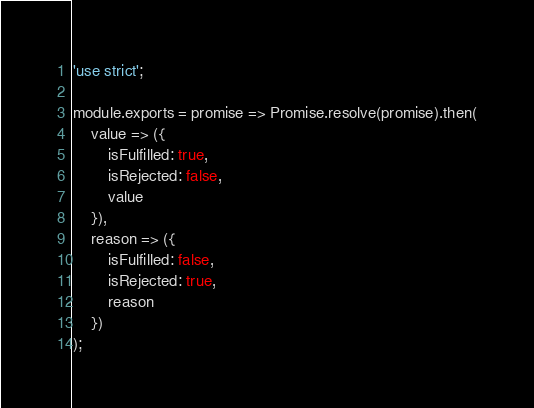<code> <loc_0><loc_0><loc_500><loc_500><_JavaScript_>'use strict';

module.exports = promise => Promise.resolve(promise).then(
	value => ({
		isFulfilled: true,
		isRejected: false,
		value
	}),
	reason => ({
		isFulfilled: false,
		isRejected: true,
		reason
	})
);
</code> 